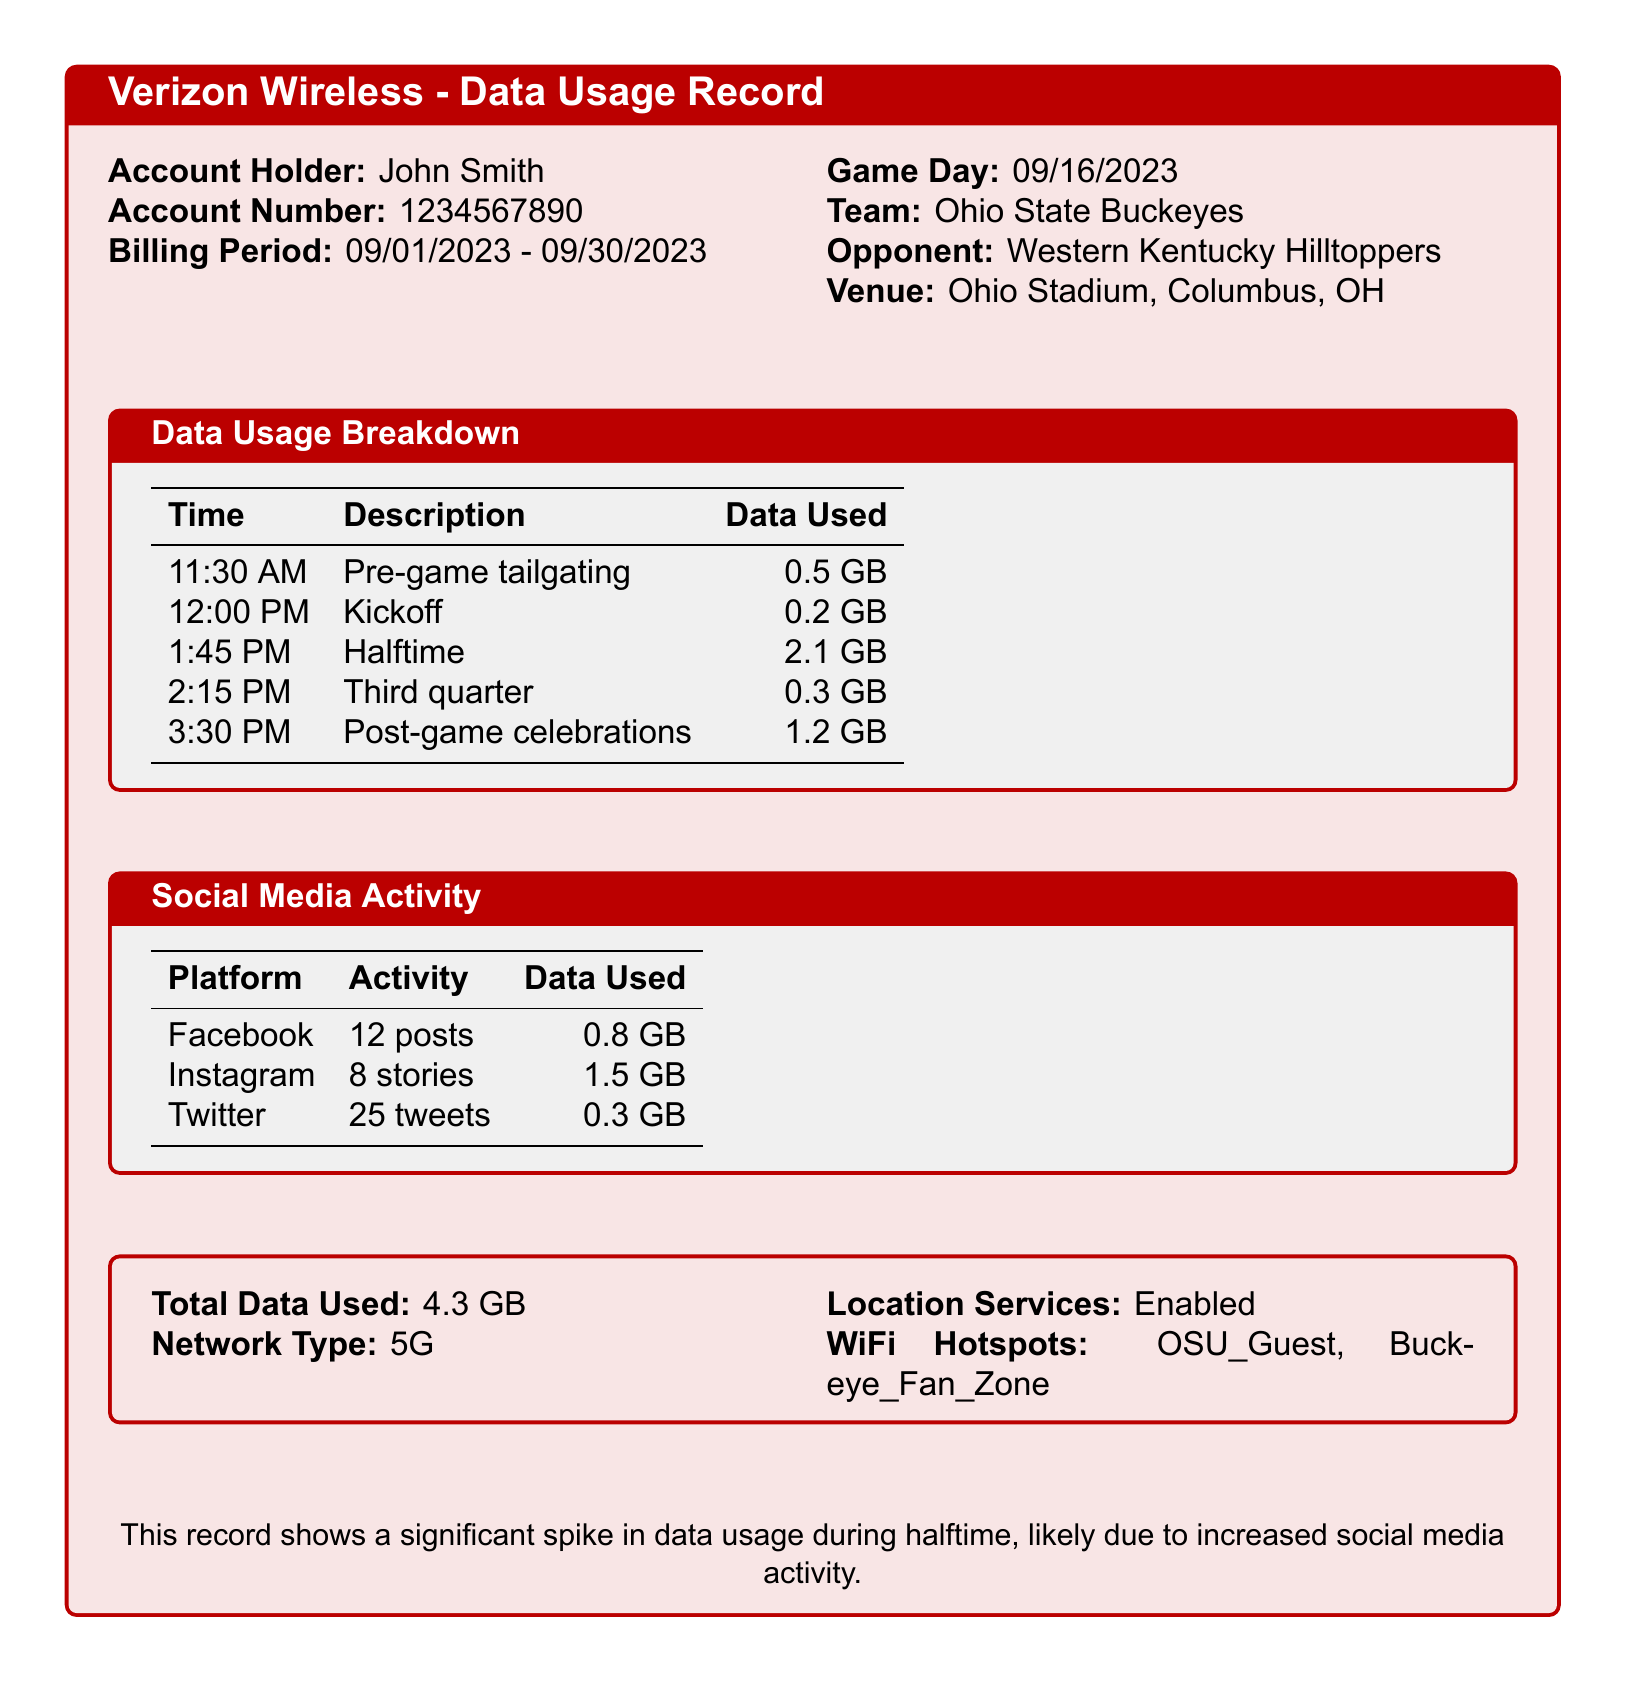What is the date of the game day? The game day is specified in the document, showing the date as 09/16/2023.
Answer: 09/16/2023 What team did the Ohio State Buckeyes play against? The opponent is listed as Western Kentucky Hilltoppers in the document.
Answer: Western Kentucky Hilltoppers What was the total data used on game day? The total data used is calculated as 0.5 GB + 0.2 GB + 2.1 GB + 0.3 GB + 1.2 GB, which totals to 4.3 GB.
Answer: 4.3 GB How much data was used during halftime? Halftime is specifically mentioned as using 2.1 GB of data.
Answer: 2.1 GB What social media platform had the highest data usage? Instagram is listed with 1.5 GB, which is the highest among all the platforms.
Answer: Instagram How many tweets were made during the game day? The document indicates that 25 tweets were posted on Twitter.
Answer: 25 tweets What was the network type used during the game? The network type is mentioned as 5G, which is used throughout the game.
Answer: 5G What activity was associated with 0.5 GB of data usage? The data usage of 0.5 GB is linked to pre-game tailgating.
Answer: Pre-game tailgating What was the total data used for social media activity? The total social media data usage is calculated as 0.8 GB + 1.5 GB + 0.3 GB, which equals 2.6 GB.
Answer: 2.6 GB 